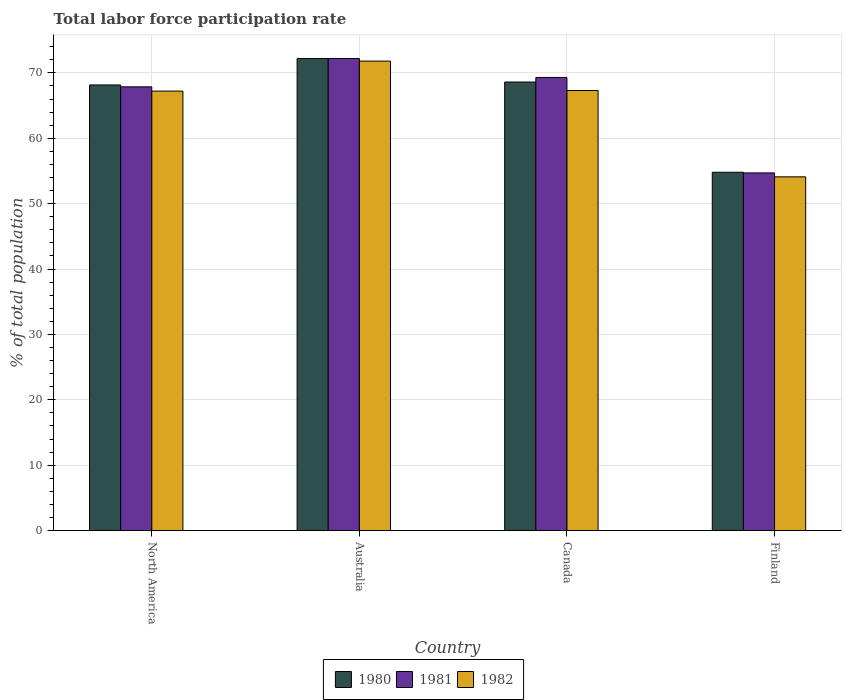How many different coloured bars are there?
Make the answer very short. 3. How many groups of bars are there?
Give a very brief answer. 4. Are the number of bars per tick equal to the number of legend labels?
Keep it short and to the point. Yes. Are the number of bars on each tick of the X-axis equal?
Ensure brevity in your answer.  Yes. How many bars are there on the 2nd tick from the left?
Give a very brief answer. 3. How many bars are there on the 1st tick from the right?
Your response must be concise. 3. What is the label of the 1st group of bars from the left?
Your answer should be compact. North America. In how many cases, is the number of bars for a given country not equal to the number of legend labels?
Offer a terse response. 0. What is the total labor force participation rate in 1981 in Finland?
Provide a succinct answer. 54.7. Across all countries, what is the maximum total labor force participation rate in 1982?
Your answer should be very brief. 71.8. Across all countries, what is the minimum total labor force participation rate in 1981?
Offer a very short reply. 54.7. In which country was the total labor force participation rate in 1980 maximum?
Make the answer very short. Australia. In which country was the total labor force participation rate in 1982 minimum?
Your answer should be very brief. Finland. What is the total total labor force participation rate in 1981 in the graph?
Offer a terse response. 264.06. What is the difference between the total labor force participation rate in 1981 in Australia and that in Finland?
Give a very brief answer. 17.5. What is the difference between the total labor force participation rate in 1980 in Australia and the total labor force participation rate in 1982 in Finland?
Your answer should be very brief. 18.1. What is the average total labor force participation rate in 1981 per country?
Ensure brevity in your answer.  66.02. What is the difference between the total labor force participation rate of/in 1982 and total labor force participation rate of/in 1981 in Finland?
Provide a succinct answer. -0.6. In how many countries, is the total labor force participation rate in 1982 greater than 18 %?
Your answer should be compact. 4. What is the ratio of the total labor force participation rate in 1981 in Australia to that in Finland?
Offer a terse response. 1.32. Is the total labor force participation rate in 1981 in Australia less than that in North America?
Give a very brief answer. No. What is the difference between the highest and the second highest total labor force participation rate in 1980?
Provide a short and direct response. 3.6. What is the difference between the highest and the lowest total labor force participation rate in 1981?
Provide a succinct answer. 17.5. Is it the case that in every country, the sum of the total labor force participation rate in 1981 and total labor force participation rate in 1982 is greater than the total labor force participation rate in 1980?
Provide a succinct answer. Yes. Are all the bars in the graph horizontal?
Give a very brief answer. No. What is the difference between two consecutive major ticks on the Y-axis?
Your answer should be compact. 10. Does the graph contain any zero values?
Give a very brief answer. No. Where does the legend appear in the graph?
Give a very brief answer. Bottom center. What is the title of the graph?
Keep it short and to the point. Total labor force participation rate. What is the label or title of the X-axis?
Your response must be concise. Country. What is the label or title of the Y-axis?
Give a very brief answer. % of total population. What is the % of total population in 1980 in North America?
Your answer should be compact. 68.15. What is the % of total population in 1981 in North America?
Make the answer very short. 67.86. What is the % of total population of 1982 in North America?
Provide a short and direct response. 67.21. What is the % of total population of 1980 in Australia?
Ensure brevity in your answer.  72.2. What is the % of total population of 1981 in Australia?
Ensure brevity in your answer.  72.2. What is the % of total population of 1982 in Australia?
Give a very brief answer. 71.8. What is the % of total population in 1980 in Canada?
Provide a short and direct response. 68.6. What is the % of total population of 1981 in Canada?
Your answer should be compact. 69.3. What is the % of total population of 1982 in Canada?
Make the answer very short. 67.3. What is the % of total population of 1980 in Finland?
Offer a very short reply. 54.8. What is the % of total population of 1981 in Finland?
Keep it short and to the point. 54.7. What is the % of total population of 1982 in Finland?
Provide a succinct answer. 54.1. Across all countries, what is the maximum % of total population in 1980?
Your answer should be very brief. 72.2. Across all countries, what is the maximum % of total population in 1981?
Ensure brevity in your answer.  72.2. Across all countries, what is the maximum % of total population in 1982?
Offer a very short reply. 71.8. Across all countries, what is the minimum % of total population of 1980?
Ensure brevity in your answer.  54.8. Across all countries, what is the minimum % of total population in 1981?
Give a very brief answer. 54.7. Across all countries, what is the minimum % of total population of 1982?
Give a very brief answer. 54.1. What is the total % of total population of 1980 in the graph?
Offer a terse response. 263.75. What is the total % of total population of 1981 in the graph?
Ensure brevity in your answer.  264.06. What is the total % of total population of 1982 in the graph?
Keep it short and to the point. 260.41. What is the difference between the % of total population of 1980 in North America and that in Australia?
Your response must be concise. -4.05. What is the difference between the % of total population in 1981 in North America and that in Australia?
Your response must be concise. -4.34. What is the difference between the % of total population of 1982 in North America and that in Australia?
Make the answer very short. -4.59. What is the difference between the % of total population of 1980 in North America and that in Canada?
Provide a succinct answer. -0.45. What is the difference between the % of total population of 1981 in North America and that in Canada?
Provide a succinct answer. -1.44. What is the difference between the % of total population in 1982 in North America and that in Canada?
Your answer should be very brief. -0.09. What is the difference between the % of total population of 1980 in North America and that in Finland?
Your answer should be very brief. 13.35. What is the difference between the % of total population of 1981 in North America and that in Finland?
Your response must be concise. 13.16. What is the difference between the % of total population in 1982 in North America and that in Finland?
Make the answer very short. 13.11. What is the difference between the % of total population in 1982 in Australia and that in Canada?
Ensure brevity in your answer.  4.5. What is the difference between the % of total population of 1980 in Australia and that in Finland?
Your response must be concise. 17.4. What is the difference between the % of total population of 1981 in Australia and that in Finland?
Offer a very short reply. 17.5. What is the difference between the % of total population of 1980 in Canada and that in Finland?
Your response must be concise. 13.8. What is the difference between the % of total population in 1981 in Canada and that in Finland?
Make the answer very short. 14.6. What is the difference between the % of total population of 1980 in North America and the % of total population of 1981 in Australia?
Your answer should be compact. -4.05. What is the difference between the % of total population of 1980 in North America and the % of total population of 1982 in Australia?
Give a very brief answer. -3.65. What is the difference between the % of total population in 1981 in North America and the % of total population in 1982 in Australia?
Provide a short and direct response. -3.94. What is the difference between the % of total population in 1980 in North America and the % of total population in 1981 in Canada?
Offer a very short reply. -1.15. What is the difference between the % of total population of 1980 in North America and the % of total population of 1982 in Canada?
Make the answer very short. 0.85. What is the difference between the % of total population of 1981 in North America and the % of total population of 1982 in Canada?
Your response must be concise. 0.56. What is the difference between the % of total population in 1980 in North America and the % of total population in 1981 in Finland?
Your answer should be very brief. 13.45. What is the difference between the % of total population in 1980 in North America and the % of total population in 1982 in Finland?
Your answer should be compact. 14.05. What is the difference between the % of total population in 1981 in North America and the % of total population in 1982 in Finland?
Your response must be concise. 13.76. What is the difference between the % of total population of 1980 in Australia and the % of total population of 1982 in Finland?
Make the answer very short. 18.1. What is the difference between the % of total population in 1980 in Canada and the % of total population in 1981 in Finland?
Offer a very short reply. 13.9. What is the difference between the % of total population of 1981 in Canada and the % of total population of 1982 in Finland?
Offer a very short reply. 15.2. What is the average % of total population of 1980 per country?
Give a very brief answer. 65.94. What is the average % of total population of 1981 per country?
Provide a succinct answer. 66.02. What is the average % of total population of 1982 per country?
Offer a very short reply. 65.1. What is the difference between the % of total population of 1980 and % of total population of 1981 in North America?
Ensure brevity in your answer.  0.29. What is the difference between the % of total population in 1980 and % of total population in 1982 in North America?
Ensure brevity in your answer.  0.94. What is the difference between the % of total population of 1981 and % of total population of 1982 in North America?
Your response must be concise. 0.65. What is the difference between the % of total population in 1980 and % of total population in 1981 in Canada?
Provide a short and direct response. -0.7. What is the ratio of the % of total population of 1980 in North America to that in Australia?
Provide a short and direct response. 0.94. What is the ratio of the % of total population of 1981 in North America to that in Australia?
Offer a terse response. 0.94. What is the ratio of the % of total population in 1982 in North America to that in Australia?
Ensure brevity in your answer.  0.94. What is the ratio of the % of total population in 1980 in North America to that in Canada?
Make the answer very short. 0.99. What is the ratio of the % of total population of 1981 in North America to that in Canada?
Give a very brief answer. 0.98. What is the ratio of the % of total population in 1980 in North America to that in Finland?
Provide a succinct answer. 1.24. What is the ratio of the % of total population in 1981 in North America to that in Finland?
Your response must be concise. 1.24. What is the ratio of the % of total population in 1982 in North America to that in Finland?
Ensure brevity in your answer.  1.24. What is the ratio of the % of total population of 1980 in Australia to that in Canada?
Offer a terse response. 1.05. What is the ratio of the % of total population in 1981 in Australia to that in Canada?
Your answer should be compact. 1.04. What is the ratio of the % of total population in 1982 in Australia to that in Canada?
Your response must be concise. 1.07. What is the ratio of the % of total population in 1980 in Australia to that in Finland?
Offer a very short reply. 1.32. What is the ratio of the % of total population of 1981 in Australia to that in Finland?
Your response must be concise. 1.32. What is the ratio of the % of total population of 1982 in Australia to that in Finland?
Provide a short and direct response. 1.33. What is the ratio of the % of total population in 1980 in Canada to that in Finland?
Ensure brevity in your answer.  1.25. What is the ratio of the % of total population in 1981 in Canada to that in Finland?
Provide a short and direct response. 1.27. What is the ratio of the % of total population of 1982 in Canada to that in Finland?
Make the answer very short. 1.24. What is the difference between the highest and the second highest % of total population of 1982?
Offer a terse response. 4.5. What is the difference between the highest and the lowest % of total population in 1980?
Provide a short and direct response. 17.4. What is the difference between the highest and the lowest % of total population of 1981?
Your answer should be compact. 17.5. 